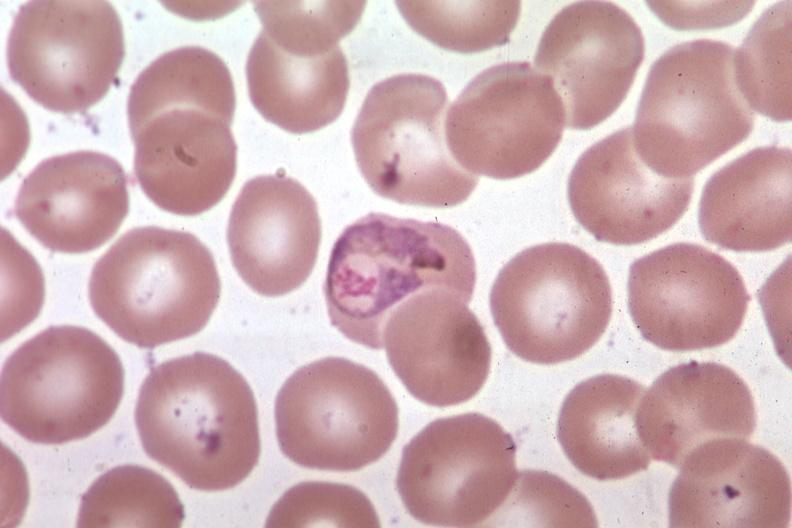s left ventricle hypertrophy present?
Answer the question using a single word or phrase. No 